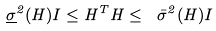<formula> <loc_0><loc_0><loc_500><loc_500>\underline { \sigma } ^ { 2 } ( H ) I \leq H ^ { T } H \leq \ \bar { \sigma } ^ { 2 } ( H ) I</formula> 